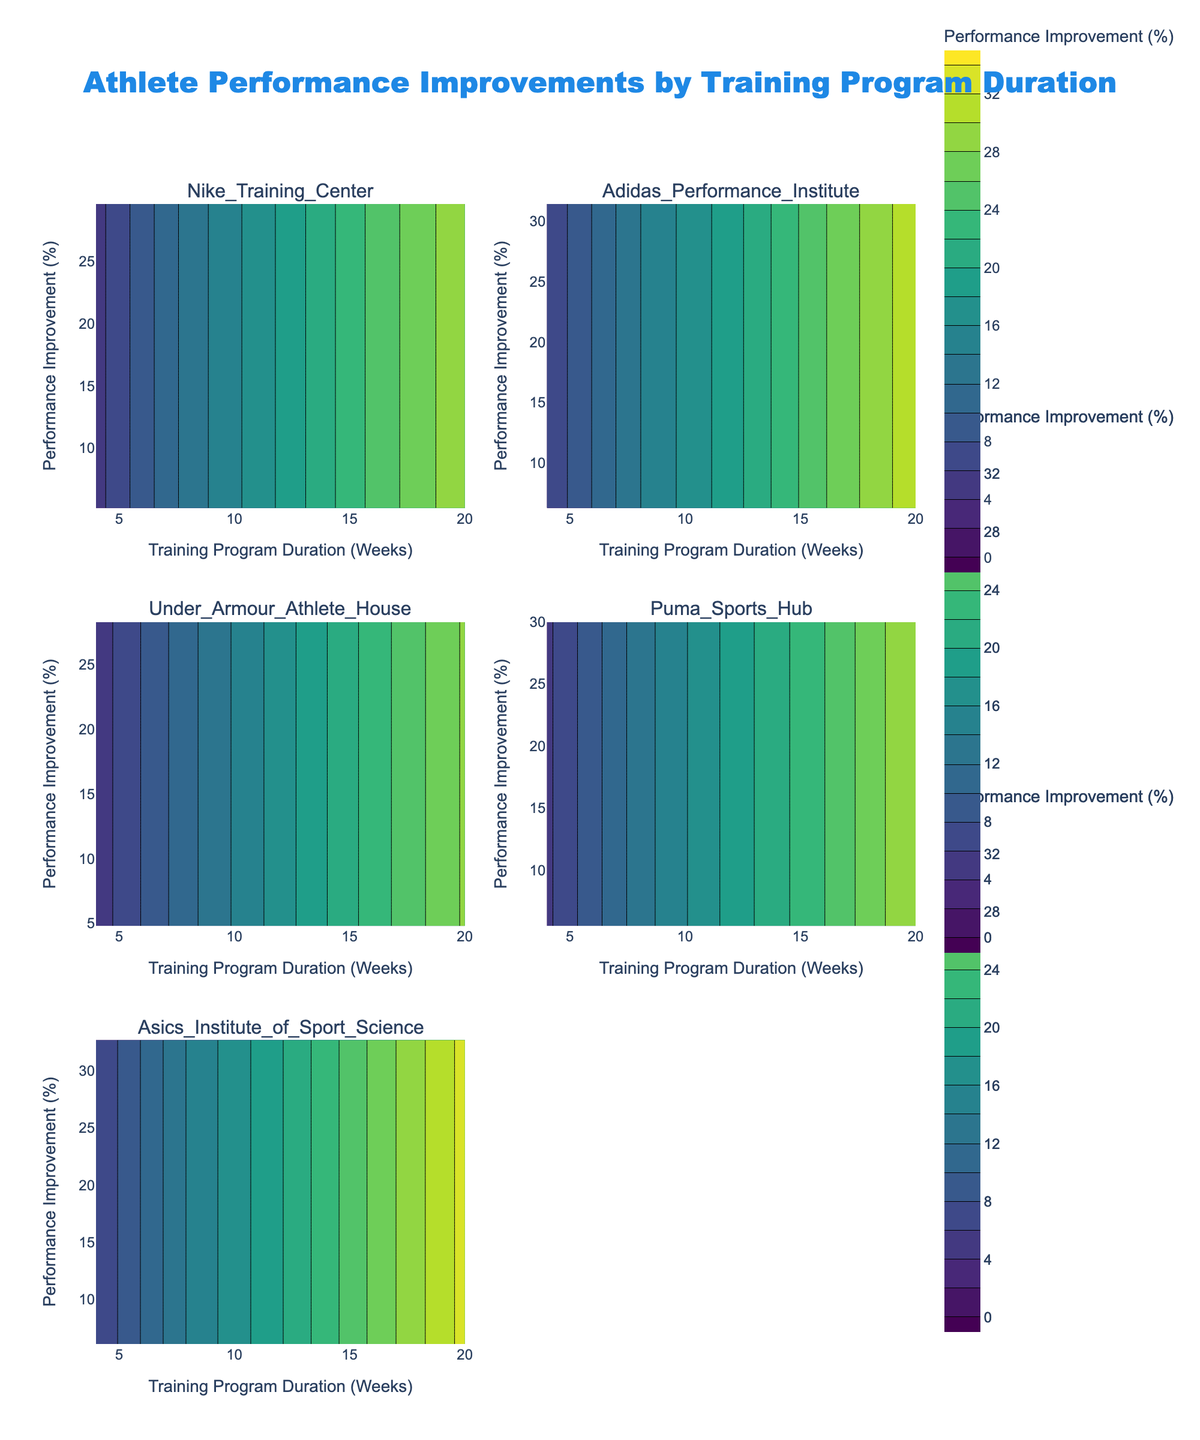How many facilities are visualized in the subplot? There are six subplot titles, and each title represents a unique facility. Therefore, there are six facilities visualized.
Answer: Six What's the title of the figure? The title is located at the top center of the figure. It reads: "Athlete Performance Improvements by Training Program Duration."
Answer: Athlete Performance Improvements by Training Program Duration Which facility shows the highest maximum performance improvement? By comparing the highest Performance Improvement Percentage across all subplots, the Asics Institute of Sport Science shows the highest maximum performance improvement at 32.7%.
Answer: Asics Institute of Sport Science What is the trend of performance improvement as the training program duration increases? Across all subplots, which represent different facilities, the performance improvement percentage consistently increases with an increase in training program duration. This indicates a positive correlation between training program duration and performance improvement.
Answer: Increases Compare the performance improvement at 16 weeks between the Nike Training Center and the Adidas Performance Institute. By examining the contours for both facilities at the 16-week mark, the Nike Training Center shows a performance improvement of 24.5%, while the Adidas Performance Institute shows 25.8%. Thus, Adidas Performance Institute has a higher performance improvement at 16 weeks.
Answer: Adidas Performance Institute Which facility has the most gradual change in performance improvement over time? By observing the contours and the gradient of colors, the Under Armour Athlete House shows the most gradual change in performance improvement. The spacing between contour lines is wider, indicating a less steep slope compared to other facilities.
Answer: Under Armour Athlete House What performance improvement is expected at 12 weeks for the Puma Sports Hub? In the subplot for Puma Sports Hub, at 12 weeks, the contour indicates a performance improvement of approximately 18.7%.
Answer: 18.7% How does the performance improvement at 8 weeks compare across all facilities? By looking at the contours at the 8-week marks for all subplots, Adidas Performance Institute has the highest performance improvement at 13.9%, followed by Asics Institute of Sport Science at 14.2%, Puma Sports Hub at 13.0%, Nike Training Center at 12.8%, and Under Armour Athlete House at 11.4%.
Answer: Adidas Performance Institute and Asics Institute of Sport Science have the highest performance improvement What's the color scale representing performance improvements? The color scale indicated by the figure goes from lighter to darker shades of the Viridis colors as performance improvement percentage increases.
Answer: Viridis colors How much performance improvement is indicated for a 4-week program at the Nike Training Center? By observing the contour lines and the data points, the performance improvement for a 4-week program at the Nike Training Center is approximately 5.2%.
Answer: 5.2% 